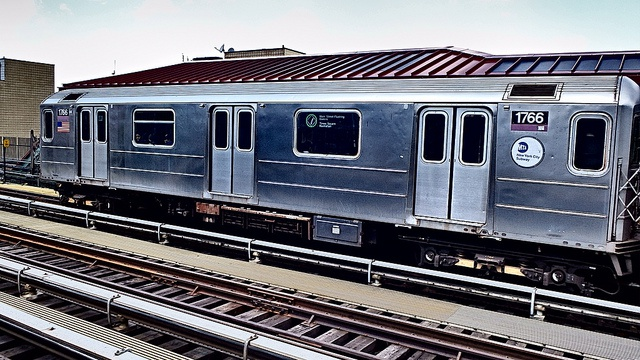Describe the objects in this image and their specific colors. I can see a train in lightgray, black, darkgray, and gray tones in this image. 